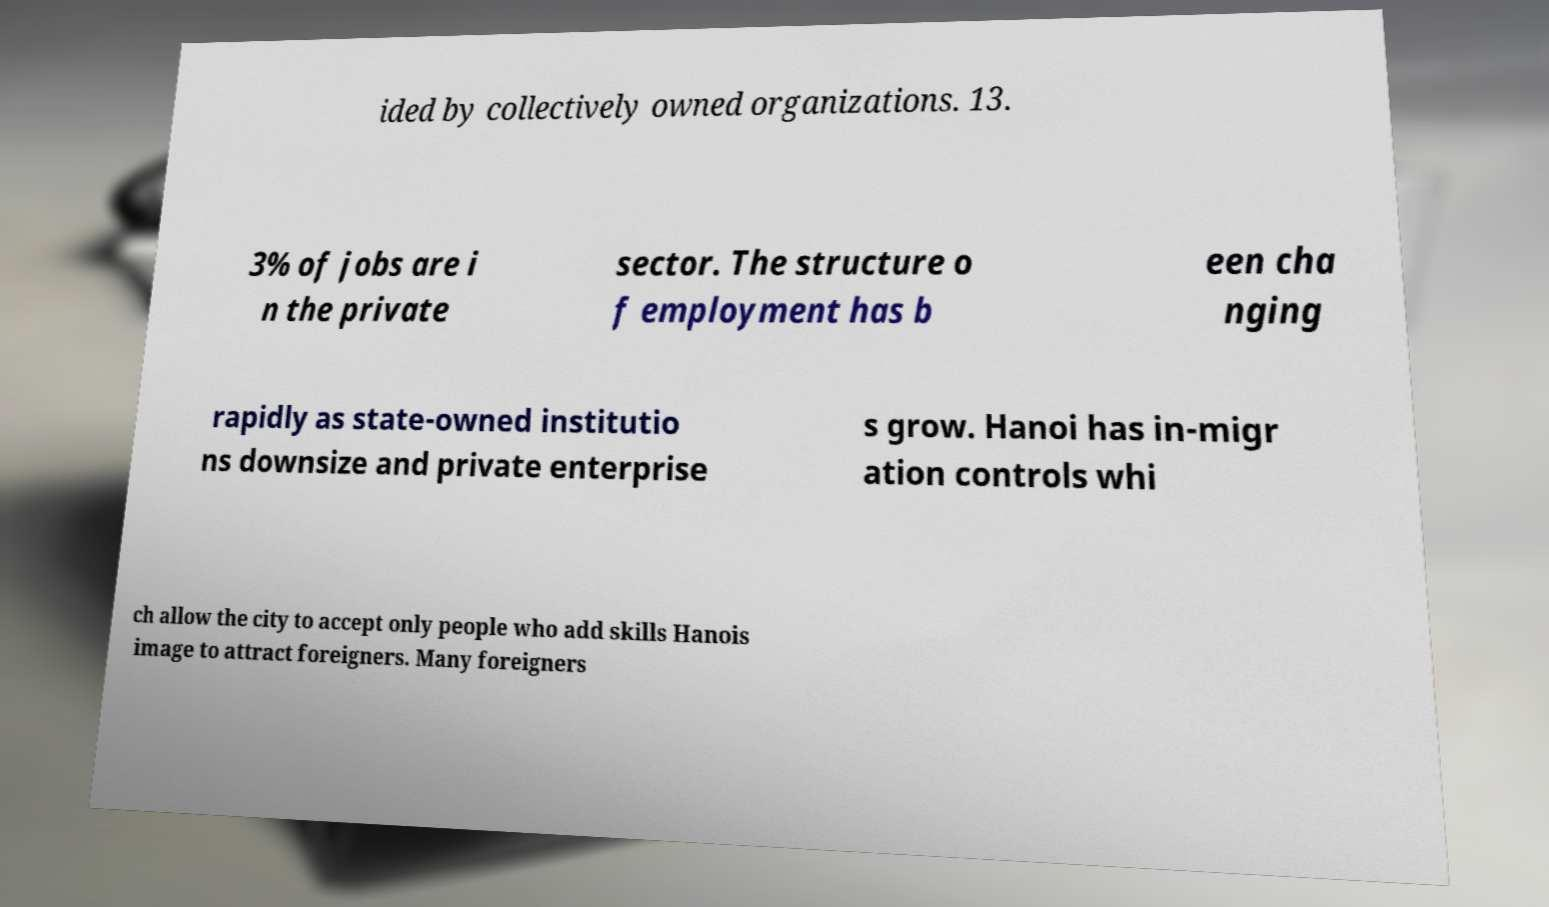Could you assist in decoding the text presented in this image and type it out clearly? ided by collectively owned organizations. 13. 3% of jobs are i n the private sector. The structure o f employment has b een cha nging rapidly as state-owned institutio ns downsize and private enterprise s grow. Hanoi has in-migr ation controls whi ch allow the city to accept only people who add skills Hanois image to attract foreigners. Many foreigners 